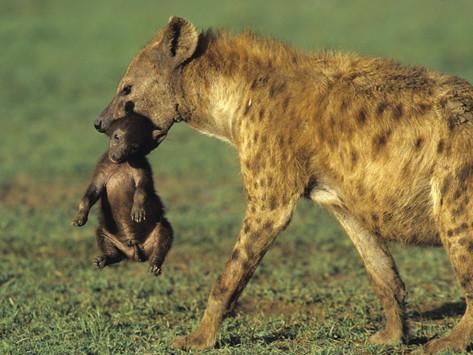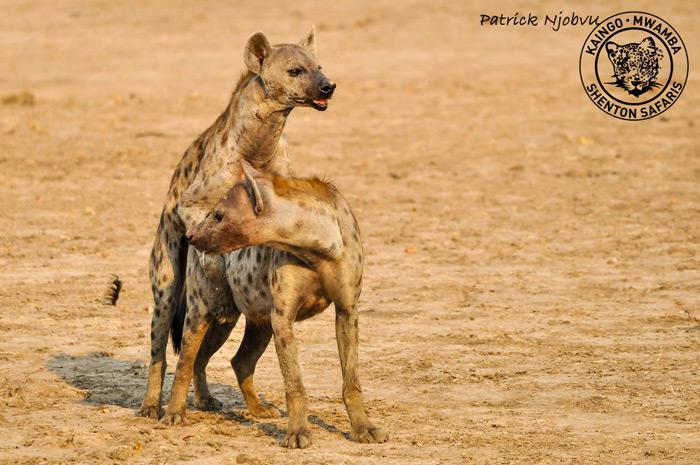The first image is the image on the left, the second image is the image on the right. Assess this claim about the two images: "The hyena in the image on the left has something in its mouth.". Correct or not? Answer yes or no. Yes. The first image is the image on the left, the second image is the image on the right. Analyze the images presented: Is the assertion "The right image contains exactly two hyenas." valid? Answer yes or no. Yes. 